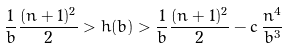<formula> <loc_0><loc_0><loc_500><loc_500>\frac { 1 } { b } \frac { ( n + 1 ) ^ { 2 } } { 2 } > h ( b ) > \frac { 1 } { b } \frac { ( n + 1 ) ^ { 2 } } { 2 } - c \, \frac { n ^ { 4 } } { b ^ { 3 } }</formula> 